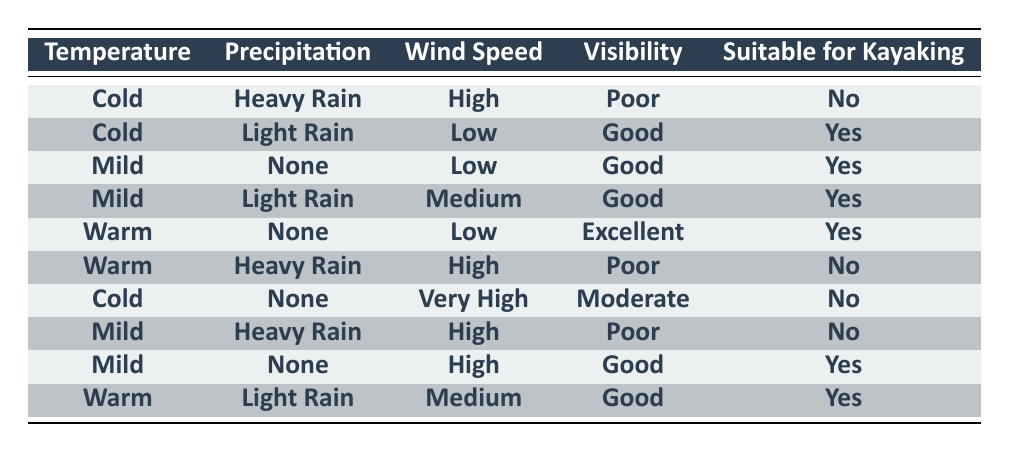What kayaking conditions are present when the temperature is warm and there is heavy rain? In the table, when the temperature is "Warm" and the precipitation is "Heavy Rain," the suitability for kayaking is "No." This matches the last row of the table.
Answer: No How many kayaker-friendly conditions are there in the dataset? The rows where suitability for kayaking is "Yes" are: Cold with Light Rain, Mild with None, Mild with Light Rain, Warm with None, Mild with None (high wind), and Warm with Light Rain. Counting these gives us 6 suitable conditions.
Answer: 6 Is kayaking suitable when the wind speed is high? From the table, there are three instances where the wind speed is "High": one with "Cold" and "Heavy Rain" (No), one with "Mild" and "Heavy Rain" (No), and one with "Mild" and "None" (Yes). Therefore, kayaking is not suitable in 2 out of 3 cases.
Answer: No What is the common visibility condition for suitable kayaking scenarios? Looking through the "suitability for kayaking" column and filtering for "Yes" (the first five rows), the visibility conditions are "Good" and "Excellent." The common condition, therefore, is "Good" as it appears in more instances.
Answer: Good When is kayaking most suitable according to the dataset? The instances that indicate suitability for kayaking correspond to Mild with None, Mild with Light Rain, Warm with None, and Warm with Light Rain. The temperature range includes Mild and Warm, but Mild has a "Good" visibility without any rain, which is generally the best fit for kayaking conditions.
Answer: Mild with None 